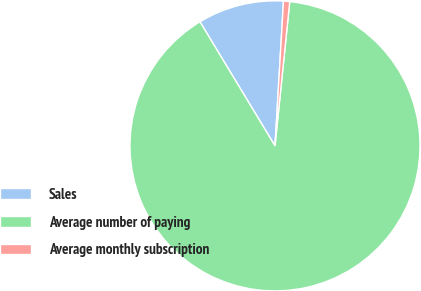<chart> <loc_0><loc_0><loc_500><loc_500><pie_chart><fcel>Sales<fcel>Average number of paying<fcel>Average monthly subscription<nl><fcel>9.59%<fcel>89.72%<fcel>0.69%<nl></chart> 